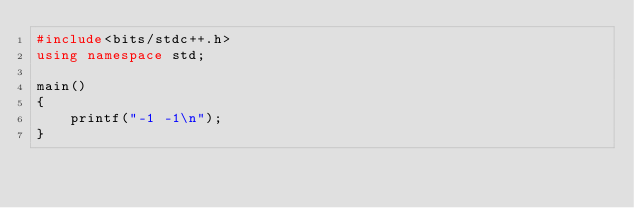<code> <loc_0><loc_0><loc_500><loc_500><_C++_>#include<bits/stdc++.h>
using namespace std;

main()
{
    printf("-1 -1\n");
}</code> 